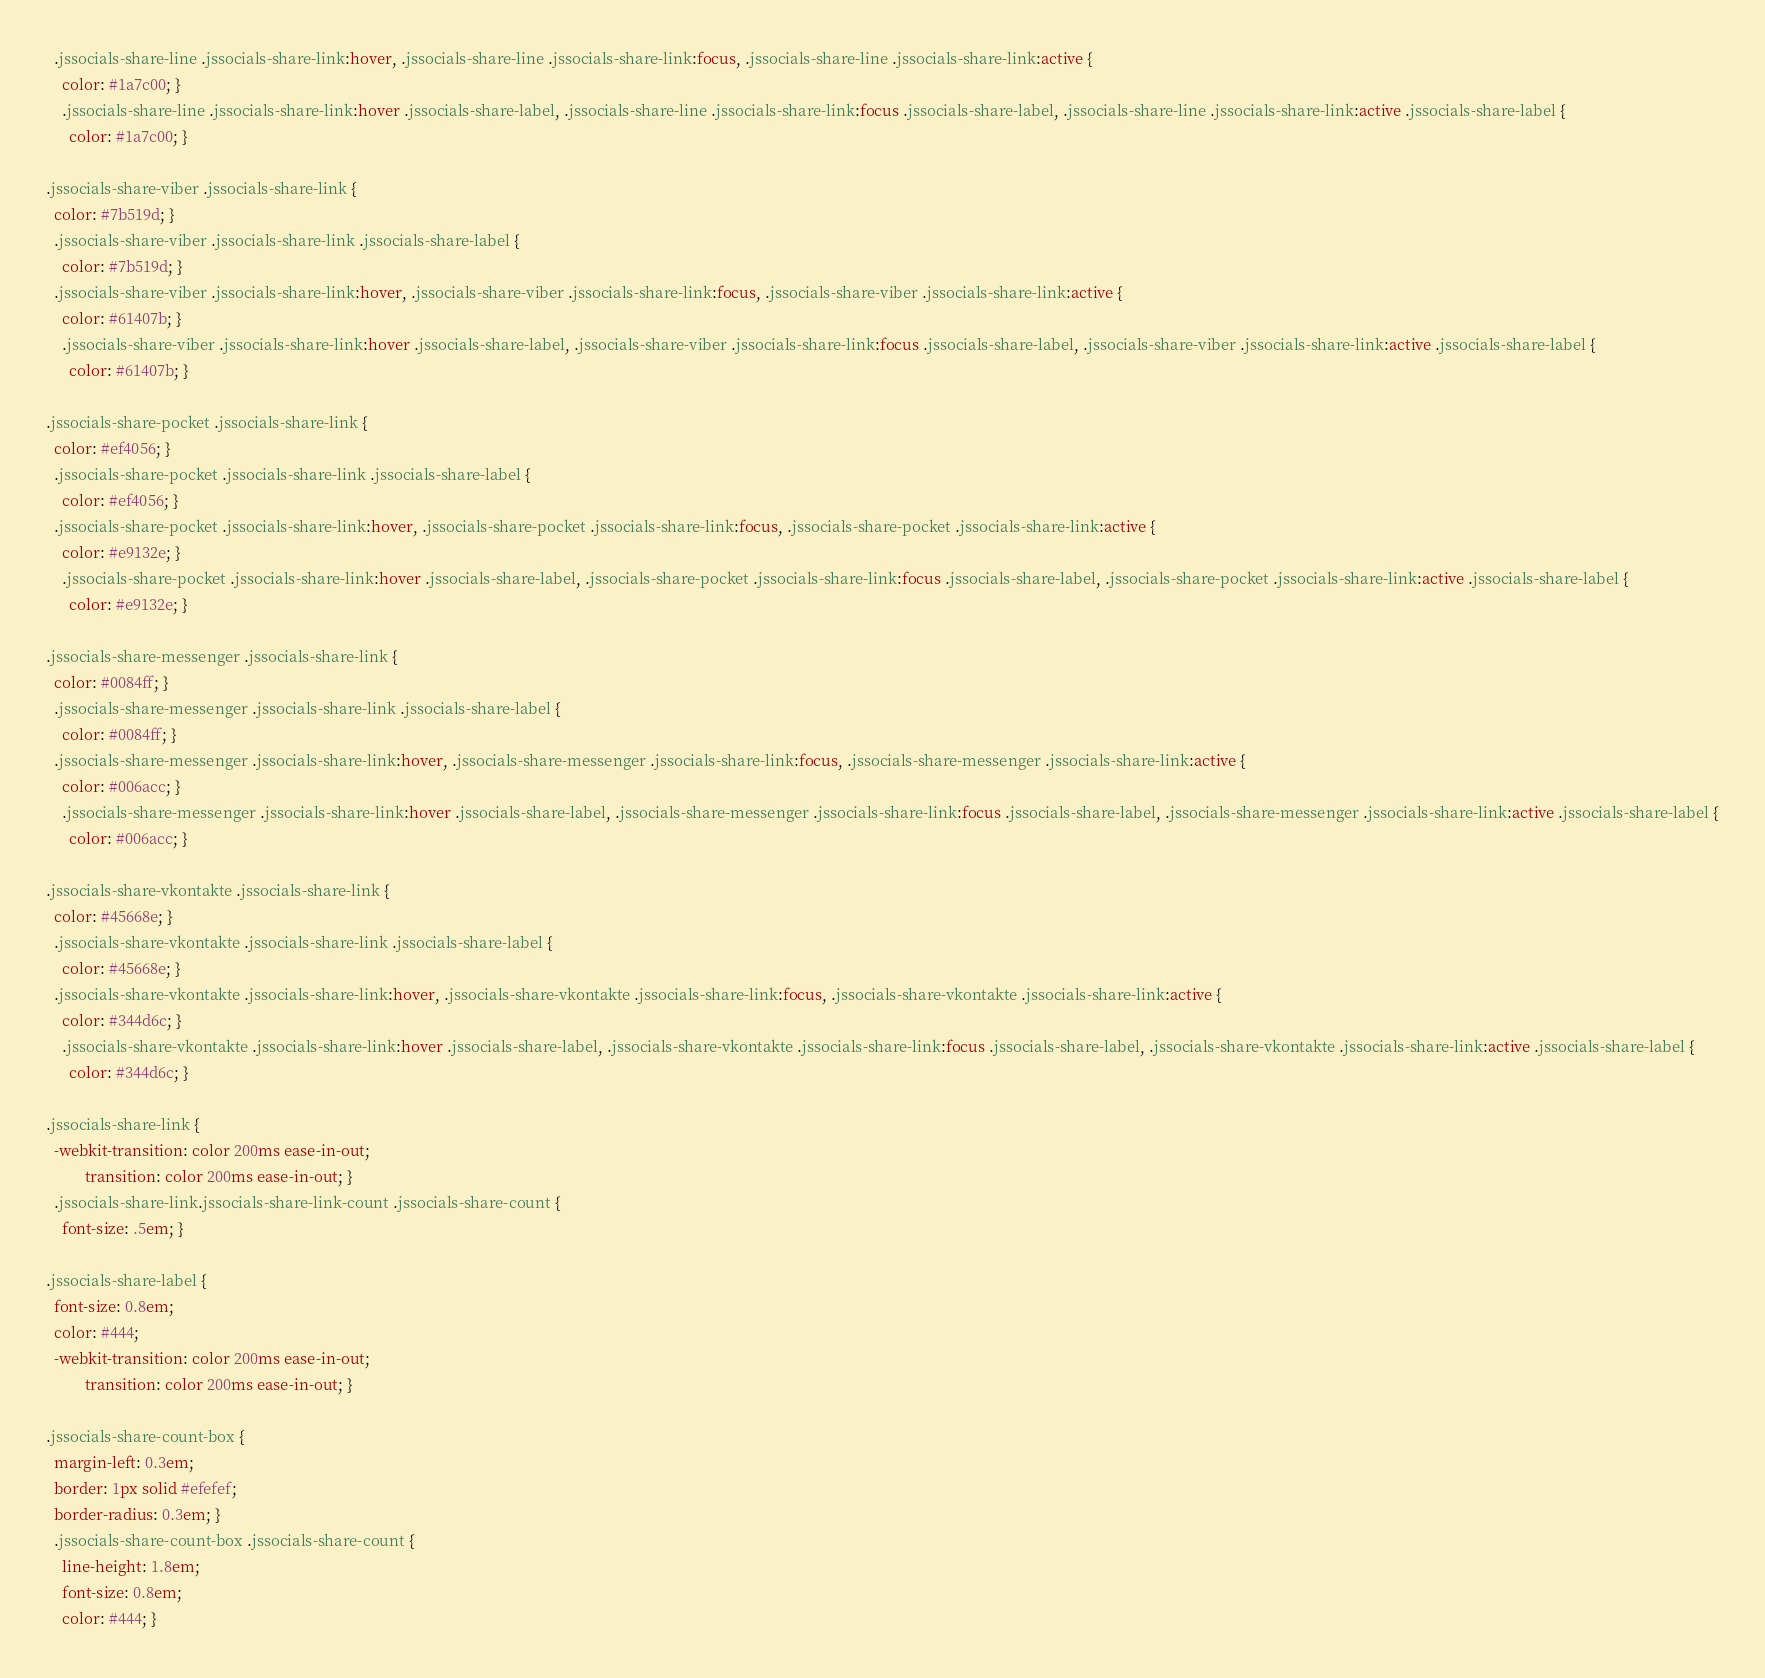<code> <loc_0><loc_0><loc_500><loc_500><_CSS_>  .jssocials-share-line .jssocials-share-link:hover, .jssocials-share-line .jssocials-share-link:focus, .jssocials-share-line .jssocials-share-link:active {
    color: #1a7c00; }
    .jssocials-share-line .jssocials-share-link:hover .jssocials-share-label, .jssocials-share-line .jssocials-share-link:focus .jssocials-share-label, .jssocials-share-line .jssocials-share-link:active .jssocials-share-label {
      color: #1a7c00; }

.jssocials-share-viber .jssocials-share-link {
  color: #7b519d; }
  .jssocials-share-viber .jssocials-share-link .jssocials-share-label {
    color: #7b519d; }
  .jssocials-share-viber .jssocials-share-link:hover, .jssocials-share-viber .jssocials-share-link:focus, .jssocials-share-viber .jssocials-share-link:active {
    color: #61407b; }
    .jssocials-share-viber .jssocials-share-link:hover .jssocials-share-label, .jssocials-share-viber .jssocials-share-link:focus .jssocials-share-label, .jssocials-share-viber .jssocials-share-link:active .jssocials-share-label {
      color: #61407b; }

.jssocials-share-pocket .jssocials-share-link {
  color: #ef4056; }
  .jssocials-share-pocket .jssocials-share-link .jssocials-share-label {
    color: #ef4056; }
  .jssocials-share-pocket .jssocials-share-link:hover, .jssocials-share-pocket .jssocials-share-link:focus, .jssocials-share-pocket .jssocials-share-link:active {
    color: #e9132e; }
    .jssocials-share-pocket .jssocials-share-link:hover .jssocials-share-label, .jssocials-share-pocket .jssocials-share-link:focus .jssocials-share-label, .jssocials-share-pocket .jssocials-share-link:active .jssocials-share-label {
      color: #e9132e; }

.jssocials-share-messenger .jssocials-share-link {
  color: #0084ff; }
  .jssocials-share-messenger .jssocials-share-link .jssocials-share-label {
    color: #0084ff; }
  .jssocials-share-messenger .jssocials-share-link:hover, .jssocials-share-messenger .jssocials-share-link:focus, .jssocials-share-messenger .jssocials-share-link:active {
    color: #006acc; }
    .jssocials-share-messenger .jssocials-share-link:hover .jssocials-share-label, .jssocials-share-messenger .jssocials-share-link:focus .jssocials-share-label, .jssocials-share-messenger .jssocials-share-link:active .jssocials-share-label {
      color: #006acc; }

.jssocials-share-vkontakte .jssocials-share-link {
  color: #45668e; }
  .jssocials-share-vkontakte .jssocials-share-link .jssocials-share-label {
    color: #45668e; }
  .jssocials-share-vkontakte .jssocials-share-link:hover, .jssocials-share-vkontakte .jssocials-share-link:focus, .jssocials-share-vkontakte .jssocials-share-link:active {
    color: #344d6c; }
    .jssocials-share-vkontakte .jssocials-share-link:hover .jssocials-share-label, .jssocials-share-vkontakte .jssocials-share-link:focus .jssocials-share-label, .jssocials-share-vkontakte .jssocials-share-link:active .jssocials-share-label {
      color: #344d6c; }

.jssocials-share-link {
  -webkit-transition: color 200ms ease-in-out;
          transition: color 200ms ease-in-out; }
  .jssocials-share-link.jssocials-share-link-count .jssocials-share-count {
    font-size: .5em; }

.jssocials-share-label {
  font-size: 0.8em;
  color: #444;
  -webkit-transition: color 200ms ease-in-out;
          transition: color 200ms ease-in-out; }

.jssocials-share-count-box {
  margin-left: 0.3em;
  border: 1px solid #efefef;
  border-radius: 0.3em; }
  .jssocials-share-count-box .jssocials-share-count {
    line-height: 1.8em;
    font-size: 0.8em;
    color: #444; }
</code> 